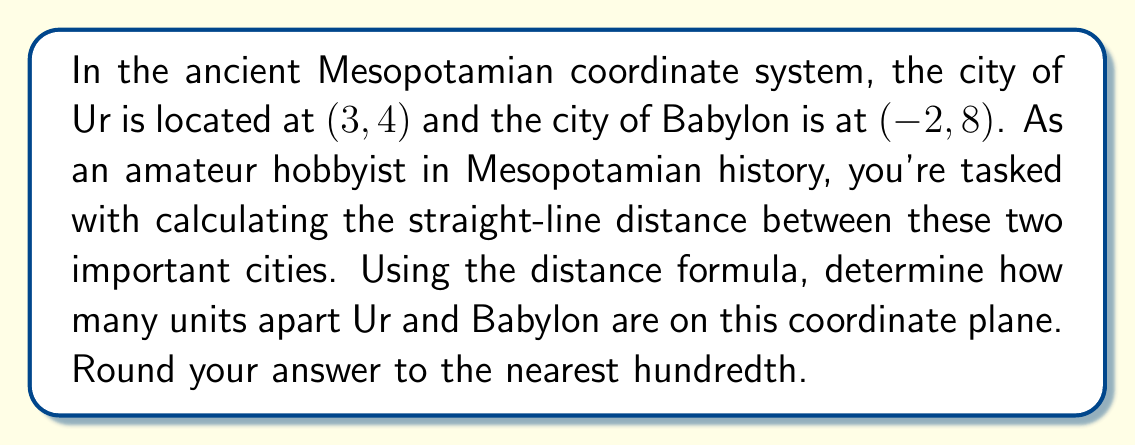Give your solution to this math problem. To solve this problem, we'll use the distance formula, which is derived from the Pythagorean theorem. The distance formula for two points $(x_1, y_1)$ and $(x_2, y_2)$ is:

$$d = \sqrt{(x_2 - x_1)^2 + (y_2 - y_1)^2}$$

Let's identify our points:
- Ur: $(x_1, y_1) = (3, 4)$
- Babylon: $(x_2, y_2) = (-2, 8)$

Now, let's plug these values into the formula:

$$\begin{align}
d &= \sqrt{(-2 - 3)^2 + (8 - 4)^2} \\
&= \sqrt{(-5)^2 + (4)^2} \\
&= \sqrt{25 + 16} \\
&= \sqrt{41} \\
&\approx 6.40312423743285
\end{align}$$

Rounding to the nearest hundredth, we get 6.40 units.

[asy]
import geometry;

unitsize(1cm);

pair Ur = (3,4);
pair Babylon = (-2,8);

dot("Ur", Ur, SE);
dot("Babylon", Babylon, NW);

draw(Ur--Babylon, blue);

xaxis(-3,4,Arrow);
yaxis(0,9,Arrow);

label("x", (4,0), E);
label("y", (0,9), N);
[/asy]

This diagram illustrates the positions of Ur and Babylon on the coordinate plane, with the blue line representing the distance between them.
Answer: The distance between Ur and Babylon is approximately 6.40 units. 